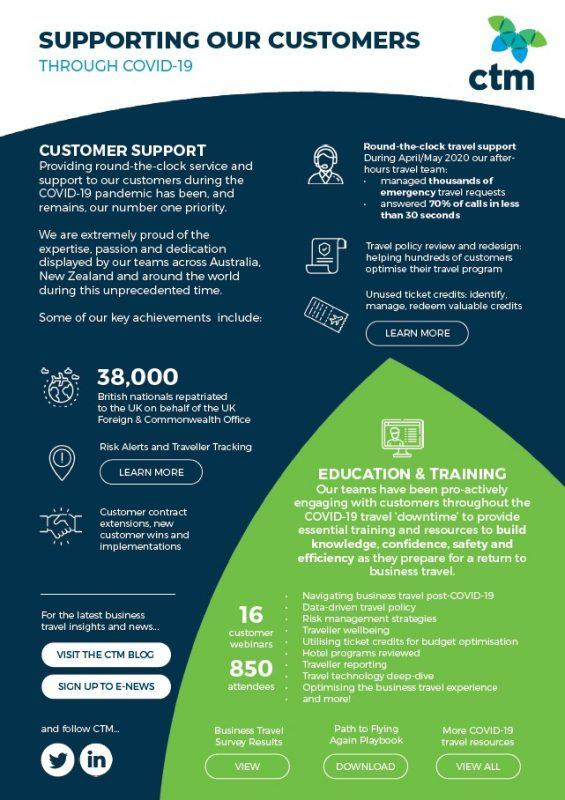List a handful of essential elements in this visual. There have been 16 customer webinars. A total of 38,000 British nationals were repatriated to the United Kingdom. The number of attendees is 850. 